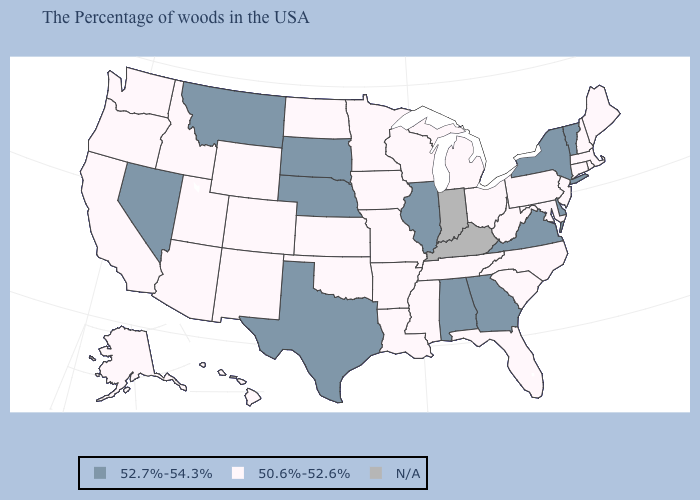What is the lowest value in the South?
Be succinct. 50.6%-52.6%. What is the value of Illinois?
Be succinct. 52.7%-54.3%. What is the value of Utah?
Quick response, please. 50.6%-52.6%. What is the highest value in the South ?
Concise answer only. 52.7%-54.3%. What is the value of Wyoming?
Concise answer only. 50.6%-52.6%. Name the states that have a value in the range N/A?
Give a very brief answer. Kentucky, Indiana. What is the value of Idaho?
Keep it brief. 50.6%-52.6%. Name the states that have a value in the range 52.7%-54.3%?
Quick response, please. Vermont, New York, Delaware, Virginia, Georgia, Alabama, Illinois, Nebraska, Texas, South Dakota, Montana, Nevada. Which states hav the highest value in the MidWest?
Quick response, please. Illinois, Nebraska, South Dakota. Name the states that have a value in the range N/A?
Keep it brief. Kentucky, Indiana. What is the lowest value in the USA?
Concise answer only. 50.6%-52.6%. How many symbols are there in the legend?
Write a very short answer. 3. Among the states that border Mississippi , which have the lowest value?
Concise answer only. Tennessee, Louisiana, Arkansas. What is the value of Missouri?
Concise answer only. 50.6%-52.6%. 